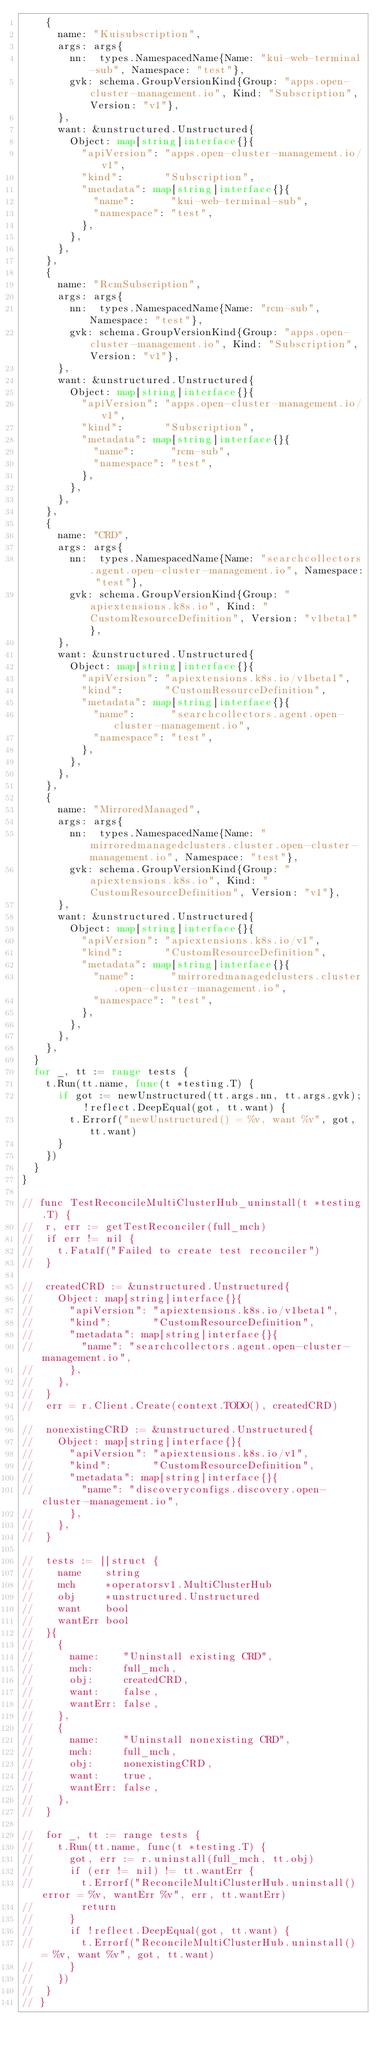Convert code to text. <code><loc_0><loc_0><loc_500><loc_500><_Go_>		{
			name: "Kuisubscription",
			args: args{
				nn:  types.NamespacedName{Name: "kui-web-terminal-sub", Namespace: "test"},
				gvk: schema.GroupVersionKind{Group: "apps.open-cluster-management.io", Kind: "Subscription", Version: "v1"},
			},
			want: &unstructured.Unstructured{
				Object: map[string]interface{}{
					"apiVersion": "apps.open-cluster-management.io/v1",
					"kind":       "Subscription",
					"metadata": map[string]interface{}{
						"name":      "kui-web-terminal-sub",
						"namespace": "test",
					},
				},
			},
		},
		{
			name: "RcmSubscription",
			args: args{
				nn:  types.NamespacedName{Name: "rcm-sub", Namespace: "test"},
				gvk: schema.GroupVersionKind{Group: "apps.open-cluster-management.io", Kind: "Subscription", Version: "v1"},
			},
			want: &unstructured.Unstructured{
				Object: map[string]interface{}{
					"apiVersion": "apps.open-cluster-management.io/v1",
					"kind":       "Subscription",
					"metadata": map[string]interface{}{
						"name":      "rcm-sub",
						"namespace": "test",
					},
				},
			},
		},
		{
			name: "CRD",
			args: args{
				nn:  types.NamespacedName{Name: "searchcollectors.agent.open-cluster-management.io", Namespace: "test"},
				gvk: schema.GroupVersionKind{Group: "apiextensions.k8s.io", Kind: "CustomResourceDefinition", Version: "v1beta1"},
			},
			want: &unstructured.Unstructured{
				Object: map[string]interface{}{
					"apiVersion": "apiextensions.k8s.io/v1beta1",
					"kind":       "CustomResourceDefinition",
					"metadata": map[string]interface{}{
						"name":      "searchcollectors.agent.open-cluster-management.io",
						"namespace": "test",
					},
				},
			},
		},
		{
			name: "MirroredManaged",
			args: args{
				nn:  types.NamespacedName{Name: "mirroredmanagedclusters.cluster.open-cluster-management.io", Namespace: "test"},
				gvk: schema.GroupVersionKind{Group: "apiextensions.k8s.io", Kind: "CustomResourceDefinition", Version: "v1"},
			},
			want: &unstructured.Unstructured{
				Object: map[string]interface{}{
					"apiVersion": "apiextensions.k8s.io/v1",
					"kind":       "CustomResourceDefinition",
					"metadata": map[string]interface{}{
						"name":      "mirroredmanagedclusters.cluster.open-cluster-management.io",
						"namespace": "test",
					},
				},
			},
		},
	}
	for _, tt := range tests {
		t.Run(tt.name, func(t *testing.T) {
			if got := newUnstructured(tt.args.nn, tt.args.gvk); !reflect.DeepEqual(got, tt.want) {
				t.Errorf("newUnstructured() = %v, want %v", got, tt.want)
			}
		})
	}
}

// func TestReconcileMultiClusterHub_uninstall(t *testing.T) {
// 	r, err := getTestReconciler(full_mch)
// 	if err != nil {
// 		t.Fatalf("Failed to create test reconciler")
// 	}

// 	createdCRD := &unstructured.Unstructured{
// 		Object: map[string]interface{}{
// 			"apiVersion": "apiextensions.k8s.io/v1beta1",
// 			"kind":       "CustomResourceDefinition",
// 			"metadata": map[string]interface{}{
// 				"name": "searchcollectors.agent.open-cluster-management.io",
// 			},
// 		},
// 	}
// 	err = r.Client.Create(context.TODO(), createdCRD)

// 	nonexistingCRD := &unstructured.Unstructured{
// 		Object: map[string]interface{}{
// 			"apiVersion": "apiextensions.k8s.io/v1",
// 			"kind":       "CustomResourceDefinition",
// 			"metadata": map[string]interface{}{
// 				"name": "discoveryconfigs.discovery.open-cluster-management.io",
// 			},
// 		},
// 	}

// 	tests := []struct {
// 		name    string
// 		mch     *operatorsv1.MultiClusterHub
// 		obj     *unstructured.Unstructured
// 		want    bool
// 		wantErr bool
// 	}{
// 		{
// 			name:    "Uninstall existing CRD",
// 			mch:     full_mch,
// 			obj:     createdCRD,
// 			want:    false,
// 			wantErr: false,
// 		},
// 		{
// 			name:    "Uninstall nonexisting CRD",
// 			mch:     full_mch,
// 			obj:     nonexistingCRD,
// 			want:    true,
// 			wantErr: false,
// 		},
// 	}

// 	for _, tt := range tests {
// 		t.Run(tt.name, func(t *testing.T) {
// 			got, err := r.uninstall(full_mch, tt.obj)
// 			if (err != nil) != tt.wantErr {
// 				t.Errorf("ReconcileMultiClusterHub.uninstall() error = %v, wantErr %v", err, tt.wantErr)
// 				return
// 			}
// 			if !reflect.DeepEqual(got, tt.want) {
// 				t.Errorf("ReconcileMultiClusterHub.uninstall() = %v, want %v", got, tt.want)
// 			}
// 		})
// 	}
// }
</code> 